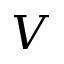Convert formula to latex. <formula><loc_0><loc_0><loc_500><loc_500>V</formula> 